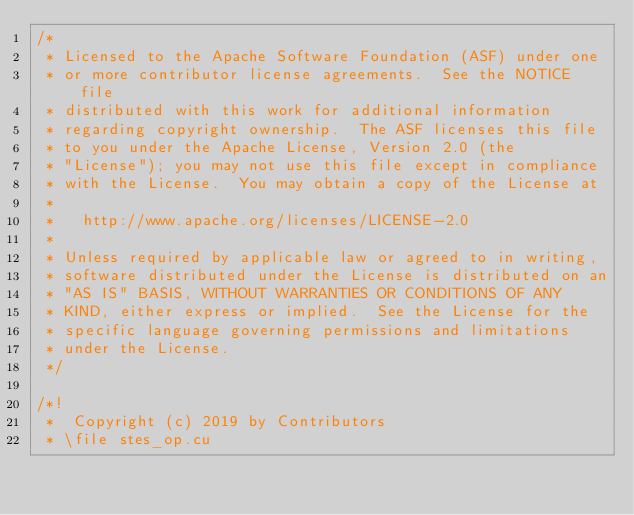<code> <loc_0><loc_0><loc_500><loc_500><_Cuda_>/*
 * Licensed to the Apache Software Foundation (ASF) under one
 * or more contributor license agreements.  See the NOTICE file
 * distributed with this work for additional information
 * regarding copyright ownership.  The ASF licenses this file
 * to you under the Apache License, Version 2.0 (the
 * "License"); you may not use this file except in compliance
 * with the License.  You may obtain a copy of the License at
 *
 *   http://www.apache.org/licenses/LICENSE-2.0
 *
 * Unless required by applicable law or agreed to in writing,
 * software distributed under the License is distributed on an
 * "AS IS" BASIS, WITHOUT WARRANTIES OR CONDITIONS OF ANY
 * KIND, either express or implied.  See the License for the
 * specific language governing permissions and limitations
 * under the License.
 */

/*!
 *  Copyright (c) 2019 by Contributors
 * \file stes_op.cu</code> 